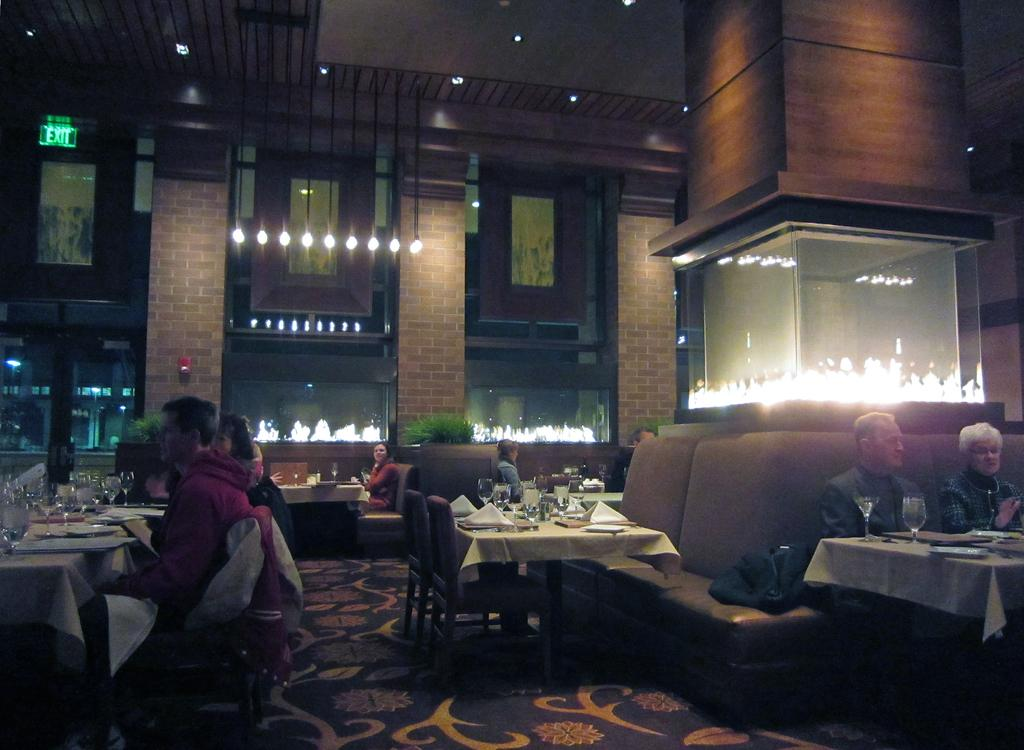What type of establishment is shown in the image? There is a restaurant in the image. What furniture is present in the restaurant? Chairs and tables are present in the restaurant. What items can be seen on the tables? There are glasses and napkins on the tables. What type of lighting is present in the restaurant? Lights are hanging above the tables in a row. How many plates are stacked on the counter in the image? There is no counter or plates visible in the image. 